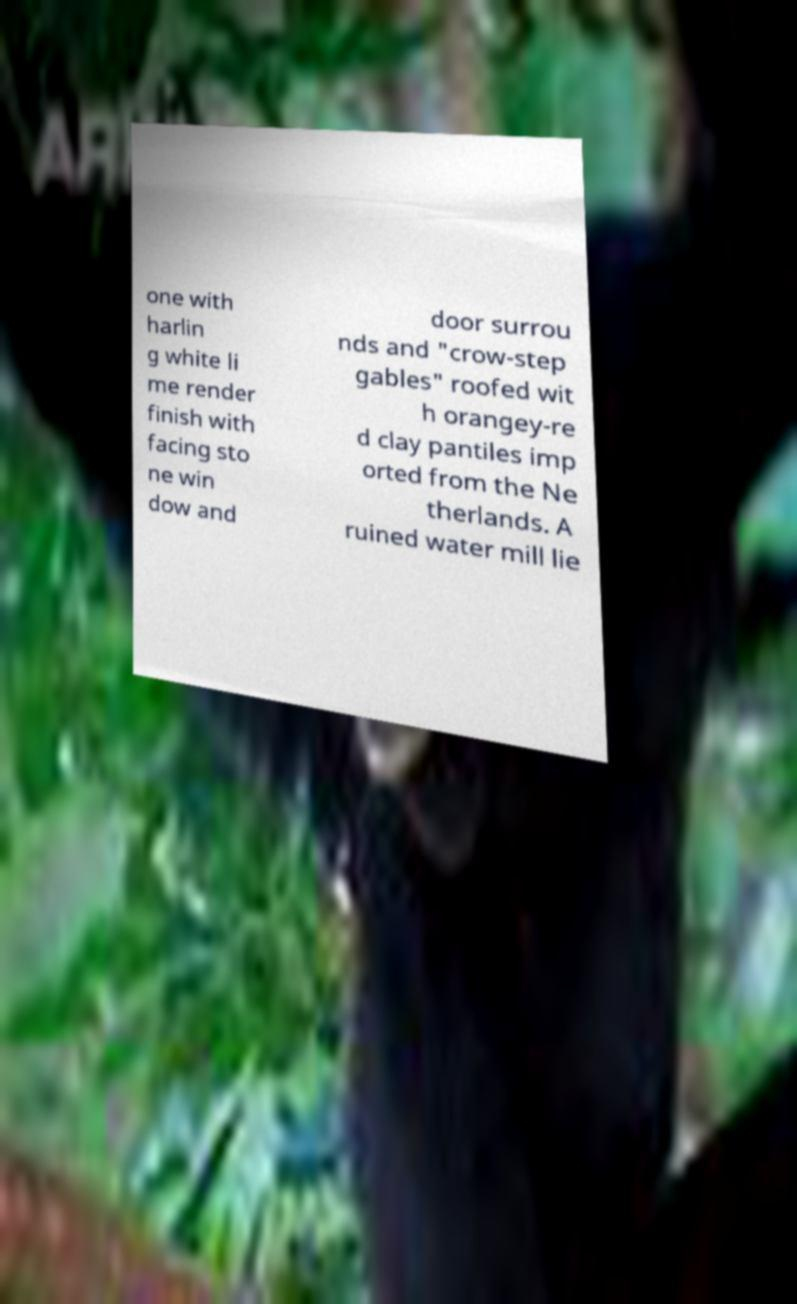There's text embedded in this image that I need extracted. Can you transcribe it verbatim? one with harlin g white li me render finish with facing sto ne win dow and door surrou nds and "crow-step gables" roofed wit h orangey-re d clay pantiles imp orted from the Ne therlands. A ruined water mill lie 